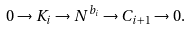Convert formula to latex. <formula><loc_0><loc_0><loc_500><loc_500>0 \to K _ { i } \to N ^ { b _ { i } } \to C _ { i + 1 } \to 0 .</formula> 